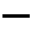<formula> <loc_0><loc_0><loc_500><loc_500>-</formula> 